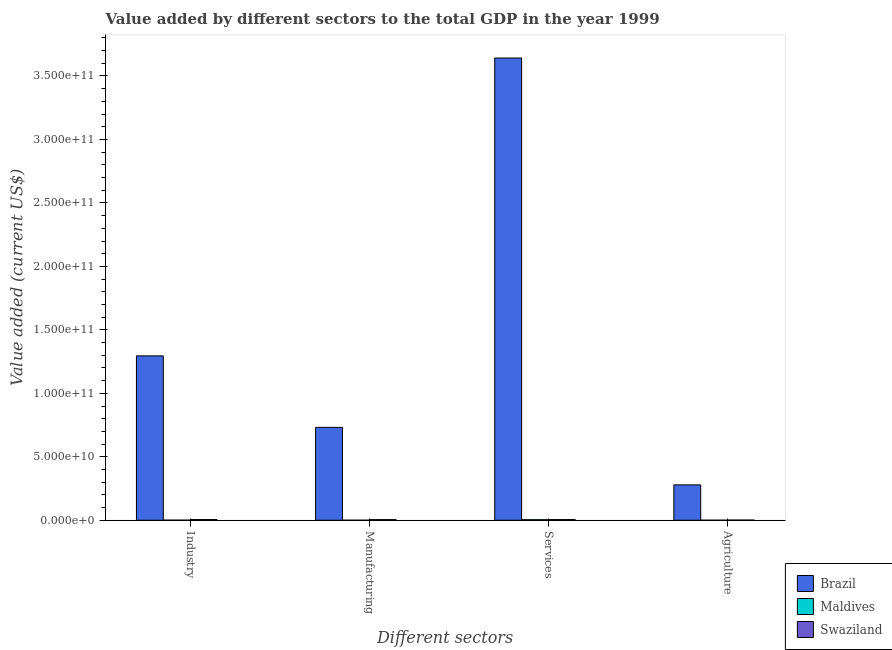How many different coloured bars are there?
Your answer should be compact. 3. How many groups of bars are there?
Make the answer very short. 4. Are the number of bars per tick equal to the number of legend labels?
Provide a short and direct response. Yes. Are the number of bars on each tick of the X-axis equal?
Provide a short and direct response. Yes. How many bars are there on the 1st tick from the left?
Your response must be concise. 3. What is the label of the 4th group of bars from the left?
Your answer should be very brief. Agriculture. What is the value added by agricultural sector in Maldives?
Provide a succinct answer. 5.42e+07. Across all countries, what is the maximum value added by agricultural sector?
Give a very brief answer. 2.79e+1. Across all countries, what is the minimum value added by agricultural sector?
Offer a very short reply. 5.42e+07. In which country was the value added by agricultural sector maximum?
Provide a short and direct response. Brazil. In which country was the value added by manufacturing sector minimum?
Offer a very short reply. Maldives. What is the total value added by manufacturing sector in the graph?
Your answer should be compact. 7.37e+1. What is the difference between the value added by agricultural sector in Maldives and that in Swaziland?
Your answer should be compact. -1.18e+08. What is the difference between the value added by manufacturing sector in Brazil and the value added by industrial sector in Swaziland?
Your answer should be compact. 7.26e+1. What is the average value added by manufacturing sector per country?
Your answer should be very brief. 2.46e+1. What is the difference between the value added by agricultural sector and value added by industrial sector in Brazil?
Give a very brief answer. -1.02e+11. In how many countries, is the value added by industrial sector greater than 330000000000 US$?
Keep it short and to the point. 0. What is the ratio of the value added by manufacturing sector in Maldives to that in Swaziland?
Give a very brief answer. 0.09. What is the difference between the highest and the second highest value added by services sector?
Ensure brevity in your answer.  3.64e+11. What is the difference between the highest and the lowest value added by industrial sector?
Your response must be concise. 1.29e+11. Is the sum of the value added by industrial sector in Brazil and Swaziland greater than the maximum value added by services sector across all countries?
Your answer should be compact. No. Is it the case that in every country, the sum of the value added by agricultural sector and value added by manufacturing sector is greater than the sum of value added by industrial sector and value added by services sector?
Your answer should be very brief. No. What does the 2nd bar from the right in Industry represents?
Ensure brevity in your answer.  Maldives. How many bars are there?
Provide a short and direct response. 12. How many countries are there in the graph?
Your answer should be very brief. 3. What is the difference between two consecutive major ticks on the Y-axis?
Provide a succinct answer. 5.00e+1. Are the values on the major ticks of Y-axis written in scientific E-notation?
Your answer should be very brief. Yes. Where does the legend appear in the graph?
Offer a very short reply. Bottom right. How many legend labels are there?
Your answer should be very brief. 3. What is the title of the graph?
Provide a short and direct response. Value added by different sectors to the total GDP in the year 1999. What is the label or title of the X-axis?
Give a very brief answer. Different sectors. What is the label or title of the Y-axis?
Your response must be concise. Value added (current US$). What is the Value added (current US$) in Brazil in Industry?
Make the answer very short. 1.30e+11. What is the Value added (current US$) in Maldives in Industry?
Your response must be concise. 9.17e+07. What is the Value added (current US$) of Swaziland in Industry?
Your answer should be very brief. 5.69e+08. What is the Value added (current US$) in Brazil in Manufacturing?
Make the answer very short. 7.32e+1. What is the Value added (current US$) of Maldives in Manufacturing?
Offer a very short reply. 4.70e+07. What is the Value added (current US$) in Swaziland in Manufacturing?
Keep it short and to the point. 4.97e+08. What is the Value added (current US$) in Brazil in Services?
Give a very brief answer. 3.64e+11. What is the Value added (current US$) in Maldives in Services?
Give a very brief answer. 4.43e+08. What is the Value added (current US$) of Swaziland in Services?
Give a very brief answer. 5.43e+08. What is the Value added (current US$) in Brazil in Agriculture?
Offer a very short reply. 2.79e+1. What is the Value added (current US$) in Maldives in Agriculture?
Provide a short and direct response. 5.42e+07. What is the Value added (current US$) in Swaziland in Agriculture?
Your response must be concise. 1.72e+08. Across all Different sectors, what is the maximum Value added (current US$) of Brazil?
Your answer should be very brief. 3.64e+11. Across all Different sectors, what is the maximum Value added (current US$) in Maldives?
Make the answer very short. 4.43e+08. Across all Different sectors, what is the maximum Value added (current US$) of Swaziland?
Keep it short and to the point. 5.69e+08. Across all Different sectors, what is the minimum Value added (current US$) of Brazil?
Make the answer very short. 2.79e+1. Across all Different sectors, what is the minimum Value added (current US$) in Maldives?
Your answer should be compact. 4.70e+07. Across all Different sectors, what is the minimum Value added (current US$) of Swaziland?
Offer a terse response. 1.72e+08. What is the total Value added (current US$) in Brazil in the graph?
Your response must be concise. 5.95e+11. What is the total Value added (current US$) of Maldives in the graph?
Offer a very short reply. 6.36e+08. What is the total Value added (current US$) in Swaziland in the graph?
Provide a succinct answer. 1.78e+09. What is the difference between the Value added (current US$) in Brazil in Industry and that in Manufacturing?
Provide a succinct answer. 5.63e+1. What is the difference between the Value added (current US$) of Maldives in Industry and that in Manufacturing?
Keep it short and to the point. 4.47e+07. What is the difference between the Value added (current US$) in Swaziland in Industry and that in Manufacturing?
Your response must be concise. 7.13e+07. What is the difference between the Value added (current US$) of Brazil in Industry and that in Services?
Keep it short and to the point. -2.35e+11. What is the difference between the Value added (current US$) in Maldives in Industry and that in Services?
Provide a succinct answer. -3.52e+08. What is the difference between the Value added (current US$) of Swaziland in Industry and that in Services?
Ensure brevity in your answer.  2.54e+07. What is the difference between the Value added (current US$) of Brazil in Industry and that in Agriculture?
Your answer should be very brief. 1.02e+11. What is the difference between the Value added (current US$) of Maldives in Industry and that in Agriculture?
Give a very brief answer. 3.75e+07. What is the difference between the Value added (current US$) in Swaziland in Industry and that in Agriculture?
Provide a short and direct response. 3.97e+08. What is the difference between the Value added (current US$) of Brazil in Manufacturing and that in Services?
Provide a short and direct response. -2.91e+11. What is the difference between the Value added (current US$) in Maldives in Manufacturing and that in Services?
Offer a very short reply. -3.96e+08. What is the difference between the Value added (current US$) of Swaziland in Manufacturing and that in Services?
Provide a short and direct response. -4.59e+07. What is the difference between the Value added (current US$) of Brazil in Manufacturing and that in Agriculture?
Offer a very short reply. 4.53e+1. What is the difference between the Value added (current US$) of Maldives in Manufacturing and that in Agriculture?
Make the answer very short. -7.16e+06. What is the difference between the Value added (current US$) of Swaziland in Manufacturing and that in Agriculture?
Make the answer very short. 3.25e+08. What is the difference between the Value added (current US$) in Brazil in Services and that in Agriculture?
Offer a terse response. 3.36e+11. What is the difference between the Value added (current US$) in Maldives in Services and that in Agriculture?
Your response must be concise. 3.89e+08. What is the difference between the Value added (current US$) of Swaziland in Services and that in Agriculture?
Ensure brevity in your answer.  3.71e+08. What is the difference between the Value added (current US$) of Brazil in Industry and the Value added (current US$) of Maldives in Manufacturing?
Your answer should be very brief. 1.29e+11. What is the difference between the Value added (current US$) of Brazil in Industry and the Value added (current US$) of Swaziland in Manufacturing?
Provide a succinct answer. 1.29e+11. What is the difference between the Value added (current US$) of Maldives in Industry and the Value added (current US$) of Swaziland in Manufacturing?
Ensure brevity in your answer.  -4.06e+08. What is the difference between the Value added (current US$) of Brazil in Industry and the Value added (current US$) of Maldives in Services?
Keep it short and to the point. 1.29e+11. What is the difference between the Value added (current US$) of Brazil in Industry and the Value added (current US$) of Swaziland in Services?
Your answer should be compact. 1.29e+11. What is the difference between the Value added (current US$) in Maldives in Industry and the Value added (current US$) in Swaziland in Services?
Keep it short and to the point. -4.52e+08. What is the difference between the Value added (current US$) in Brazil in Industry and the Value added (current US$) in Maldives in Agriculture?
Your answer should be compact. 1.29e+11. What is the difference between the Value added (current US$) of Brazil in Industry and the Value added (current US$) of Swaziland in Agriculture?
Offer a terse response. 1.29e+11. What is the difference between the Value added (current US$) of Maldives in Industry and the Value added (current US$) of Swaziland in Agriculture?
Ensure brevity in your answer.  -8.04e+07. What is the difference between the Value added (current US$) in Brazil in Manufacturing and the Value added (current US$) in Maldives in Services?
Your answer should be very brief. 7.27e+1. What is the difference between the Value added (current US$) of Brazil in Manufacturing and the Value added (current US$) of Swaziland in Services?
Provide a short and direct response. 7.26e+1. What is the difference between the Value added (current US$) in Maldives in Manufacturing and the Value added (current US$) in Swaziland in Services?
Ensure brevity in your answer.  -4.96e+08. What is the difference between the Value added (current US$) in Brazil in Manufacturing and the Value added (current US$) in Maldives in Agriculture?
Provide a short and direct response. 7.31e+1. What is the difference between the Value added (current US$) of Brazil in Manufacturing and the Value added (current US$) of Swaziland in Agriculture?
Your answer should be very brief. 7.30e+1. What is the difference between the Value added (current US$) in Maldives in Manufacturing and the Value added (current US$) in Swaziland in Agriculture?
Provide a succinct answer. -1.25e+08. What is the difference between the Value added (current US$) in Brazil in Services and the Value added (current US$) in Maldives in Agriculture?
Ensure brevity in your answer.  3.64e+11. What is the difference between the Value added (current US$) of Brazil in Services and the Value added (current US$) of Swaziland in Agriculture?
Make the answer very short. 3.64e+11. What is the difference between the Value added (current US$) in Maldives in Services and the Value added (current US$) in Swaziland in Agriculture?
Keep it short and to the point. 2.71e+08. What is the average Value added (current US$) in Brazil per Different sectors?
Ensure brevity in your answer.  1.49e+11. What is the average Value added (current US$) in Maldives per Different sectors?
Your answer should be very brief. 1.59e+08. What is the average Value added (current US$) in Swaziland per Different sectors?
Provide a short and direct response. 4.45e+08. What is the difference between the Value added (current US$) of Brazil and Value added (current US$) of Maldives in Industry?
Your answer should be compact. 1.29e+11. What is the difference between the Value added (current US$) in Brazil and Value added (current US$) in Swaziland in Industry?
Provide a succinct answer. 1.29e+11. What is the difference between the Value added (current US$) of Maldives and Value added (current US$) of Swaziland in Industry?
Offer a very short reply. -4.77e+08. What is the difference between the Value added (current US$) of Brazil and Value added (current US$) of Maldives in Manufacturing?
Provide a succinct answer. 7.31e+1. What is the difference between the Value added (current US$) of Brazil and Value added (current US$) of Swaziland in Manufacturing?
Offer a terse response. 7.27e+1. What is the difference between the Value added (current US$) of Maldives and Value added (current US$) of Swaziland in Manufacturing?
Offer a terse response. -4.50e+08. What is the difference between the Value added (current US$) of Brazil and Value added (current US$) of Maldives in Services?
Your answer should be compact. 3.64e+11. What is the difference between the Value added (current US$) of Brazil and Value added (current US$) of Swaziland in Services?
Keep it short and to the point. 3.64e+11. What is the difference between the Value added (current US$) of Maldives and Value added (current US$) of Swaziland in Services?
Give a very brief answer. -9.99e+07. What is the difference between the Value added (current US$) in Brazil and Value added (current US$) in Maldives in Agriculture?
Make the answer very short. 2.78e+1. What is the difference between the Value added (current US$) of Brazil and Value added (current US$) of Swaziland in Agriculture?
Keep it short and to the point. 2.77e+1. What is the difference between the Value added (current US$) in Maldives and Value added (current US$) in Swaziland in Agriculture?
Provide a short and direct response. -1.18e+08. What is the ratio of the Value added (current US$) in Brazil in Industry to that in Manufacturing?
Your response must be concise. 1.77. What is the ratio of the Value added (current US$) in Maldives in Industry to that in Manufacturing?
Offer a terse response. 1.95. What is the ratio of the Value added (current US$) in Swaziland in Industry to that in Manufacturing?
Provide a succinct answer. 1.14. What is the ratio of the Value added (current US$) of Brazil in Industry to that in Services?
Ensure brevity in your answer.  0.36. What is the ratio of the Value added (current US$) in Maldives in Industry to that in Services?
Your answer should be compact. 0.21. What is the ratio of the Value added (current US$) of Swaziland in Industry to that in Services?
Your answer should be very brief. 1.05. What is the ratio of the Value added (current US$) in Brazil in Industry to that in Agriculture?
Your answer should be very brief. 4.65. What is the ratio of the Value added (current US$) in Maldives in Industry to that in Agriculture?
Offer a very short reply. 1.69. What is the ratio of the Value added (current US$) in Swaziland in Industry to that in Agriculture?
Keep it short and to the point. 3.3. What is the ratio of the Value added (current US$) of Brazil in Manufacturing to that in Services?
Your response must be concise. 0.2. What is the ratio of the Value added (current US$) of Maldives in Manufacturing to that in Services?
Make the answer very short. 0.11. What is the ratio of the Value added (current US$) of Swaziland in Manufacturing to that in Services?
Provide a short and direct response. 0.92. What is the ratio of the Value added (current US$) of Brazil in Manufacturing to that in Agriculture?
Provide a short and direct response. 2.63. What is the ratio of the Value added (current US$) of Maldives in Manufacturing to that in Agriculture?
Give a very brief answer. 0.87. What is the ratio of the Value added (current US$) in Swaziland in Manufacturing to that in Agriculture?
Keep it short and to the point. 2.89. What is the ratio of the Value added (current US$) of Brazil in Services to that in Agriculture?
Make the answer very short. 13.07. What is the ratio of the Value added (current US$) of Maldives in Services to that in Agriculture?
Ensure brevity in your answer.  8.18. What is the ratio of the Value added (current US$) of Swaziland in Services to that in Agriculture?
Your answer should be very brief. 3.16. What is the difference between the highest and the second highest Value added (current US$) in Brazil?
Ensure brevity in your answer.  2.35e+11. What is the difference between the highest and the second highest Value added (current US$) of Maldives?
Your response must be concise. 3.52e+08. What is the difference between the highest and the second highest Value added (current US$) in Swaziland?
Ensure brevity in your answer.  2.54e+07. What is the difference between the highest and the lowest Value added (current US$) of Brazil?
Give a very brief answer. 3.36e+11. What is the difference between the highest and the lowest Value added (current US$) in Maldives?
Make the answer very short. 3.96e+08. What is the difference between the highest and the lowest Value added (current US$) of Swaziland?
Provide a succinct answer. 3.97e+08. 